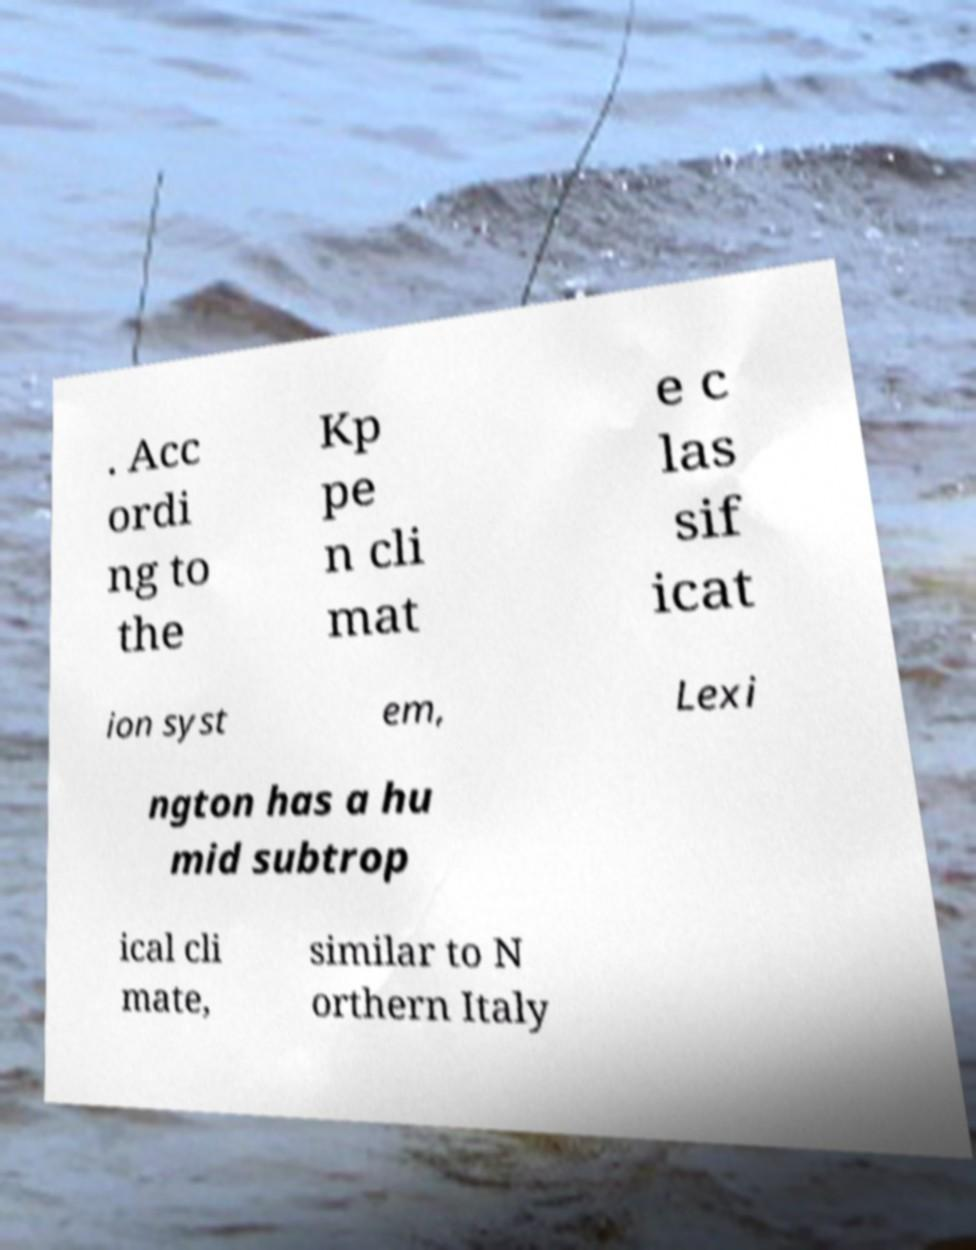Can you read and provide the text displayed in the image?This photo seems to have some interesting text. Can you extract and type it out for me? . Acc ordi ng to the Kp pe n cli mat e c las sif icat ion syst em, Lexi ngton has a hu mid subtrop ical cli mate, similar to N orthern Italy 